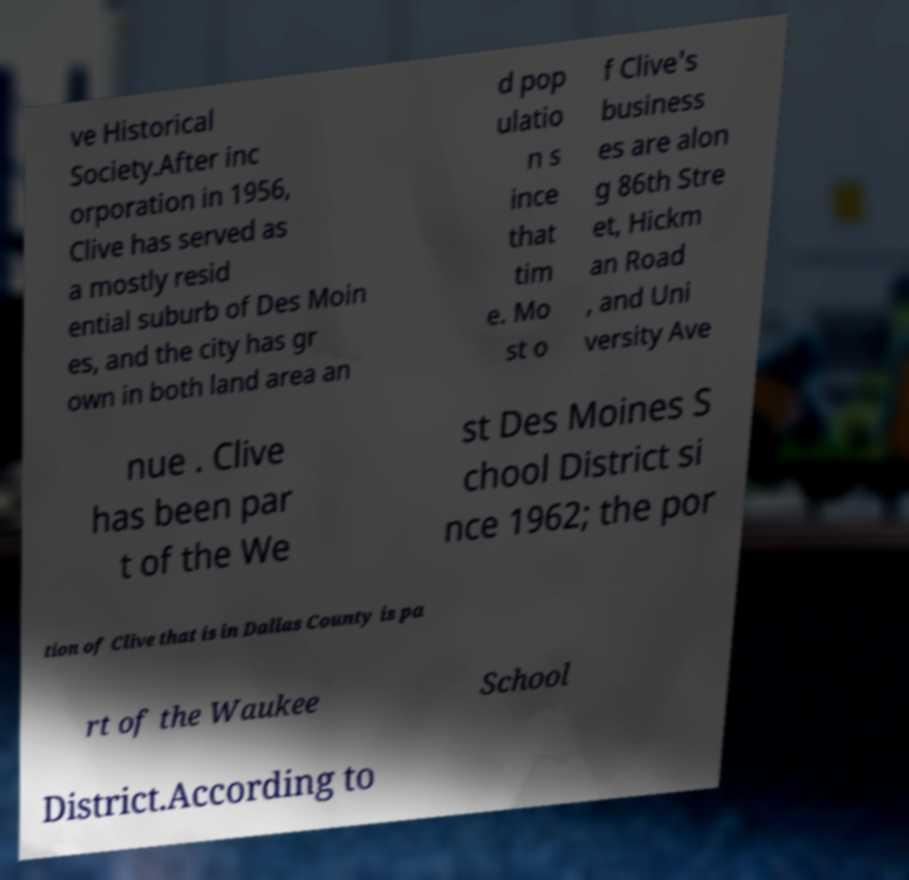Can you read and provide the text displayed in the image?This photo seems to have some interesting text. Can you extract and type it out for me? ve Historical Society.After inc orporation in 1956, Clive has served as a mostly resid ential suburb of Des Moin es, and the city has gr own in both land area an d pop ulatio n s ince that tim e. Mo st o f Clive's business es are alon g 86th Stre et, Hickm an Road , and Uni versity Ave nue . Clive has been par t of the We st Des Moines S chool District si nce 1962; the por tion of Clive that is in Dallas County is pa rt of the Waukee School District.According to 